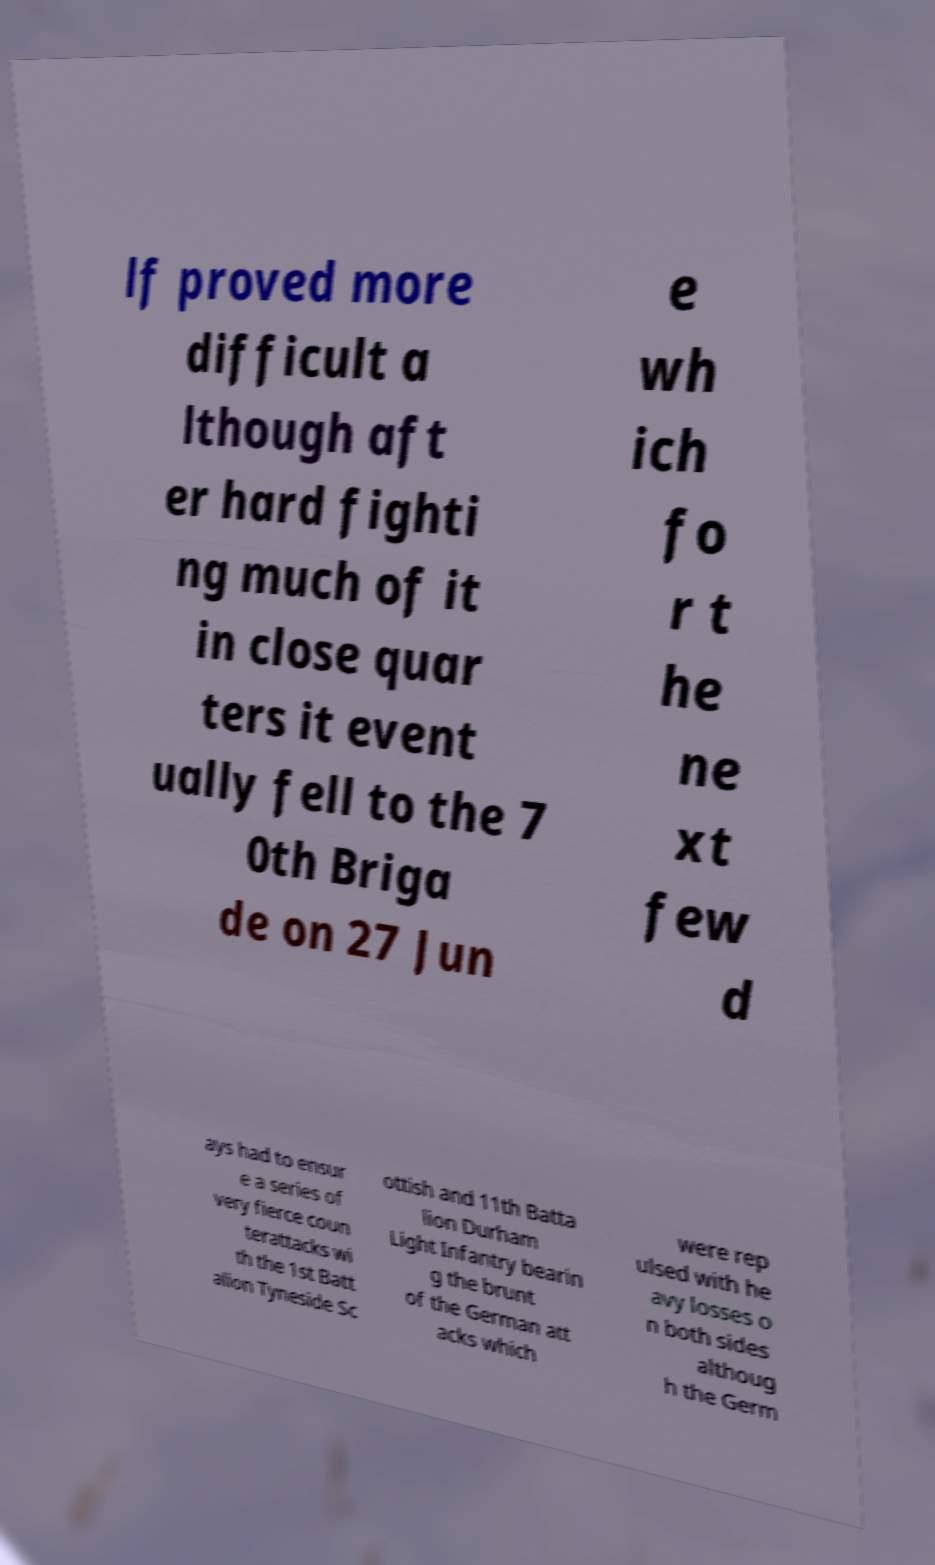For documentation purposes, I need the text within this image transcribed. Could you provide that? lf proved more difficult a lthough aft er hard fighti ng much of it in close quar ters it event ually fell to the 7 0th Briga de on 27 Jun e wh ich fo r t he ne xt few d ays had to ensur e a series of very fierce coun terattacks wi th the 1st Batt alion Tyneside Sc ottish and 11th Batta lion Durham Light Infantry bearin g the brunt of the German att acks which were rep ulsed with he avy losses o n both sides althoug h the Germ 